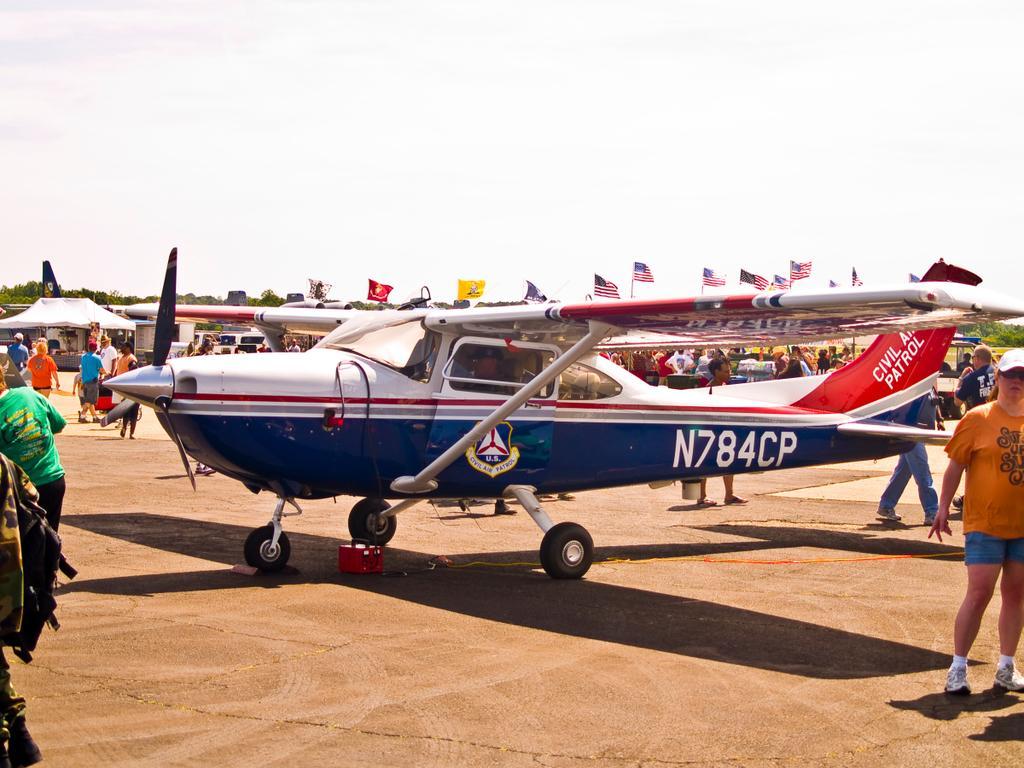Could you give a brief overview of what you see in this image? In this image there is an airplane on the land. There are people walking on the land. Left side there is a tent. Behind the airplane there are flags attached to the poles. Right side there is a person wearing a cap. He is standing on the land. Background there are trees. Top of the image there is sky. 